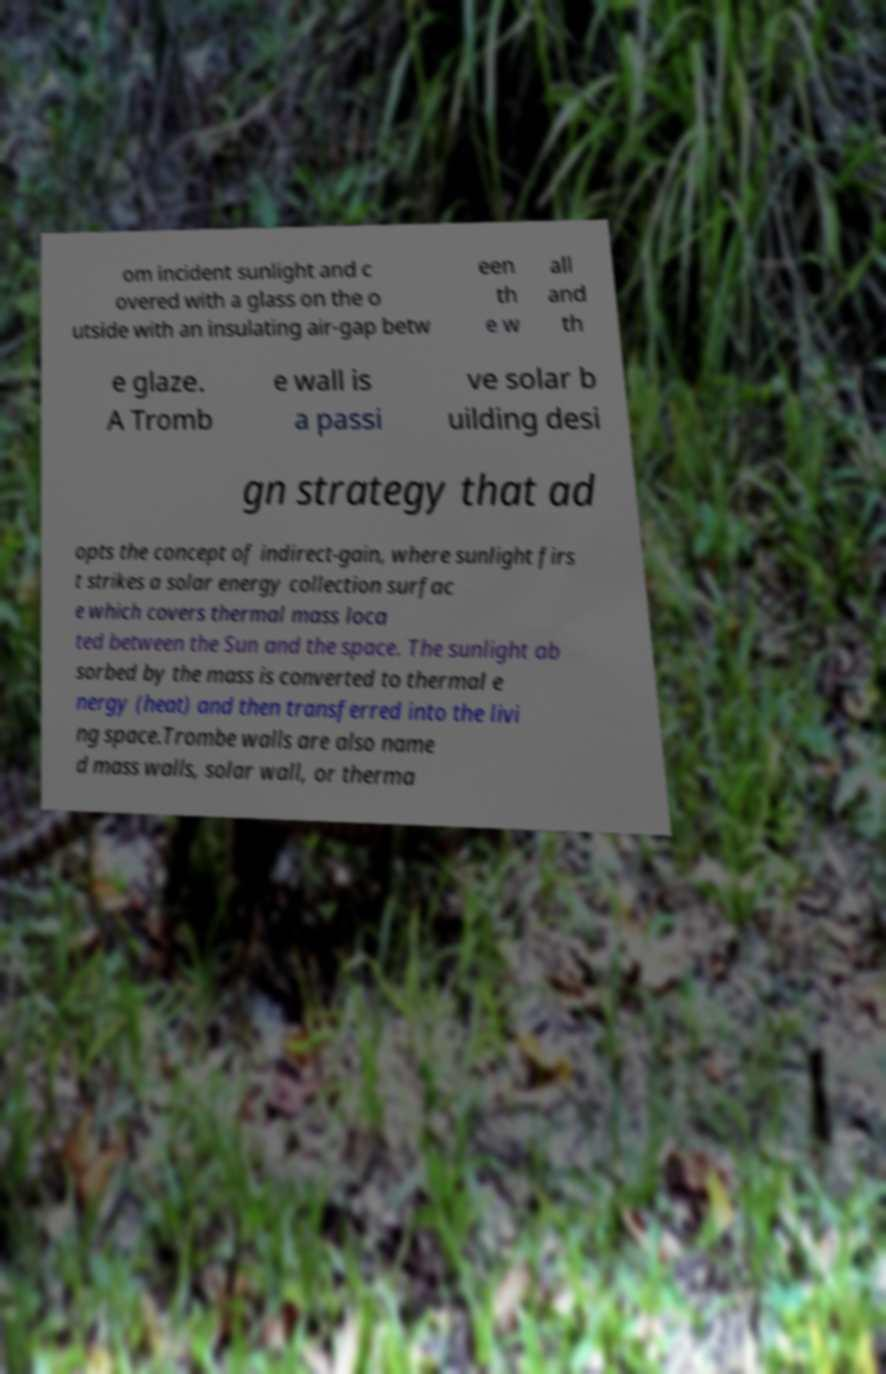For documentation purposes, I need the text within this image transcribed. Could you provide that? om incident sunlight and c overed with a glass on the o utside with an insulating air-gap betw een th e w all and th e glaze. A Tromb e wall is a passi ve solar b uilding desi gn strategy that ad opts the concept of indirect-gain, where sunlight firs t strikes a solar energy collection surfac e which covers thermal mass loca ted between the Sun and the space. The sunlight ab sorbed by the mass is converted to thermal e nergy (heat) and then transferred into the livi ng space.Trombe walls are also name d mass walls, solar wall, or therma 